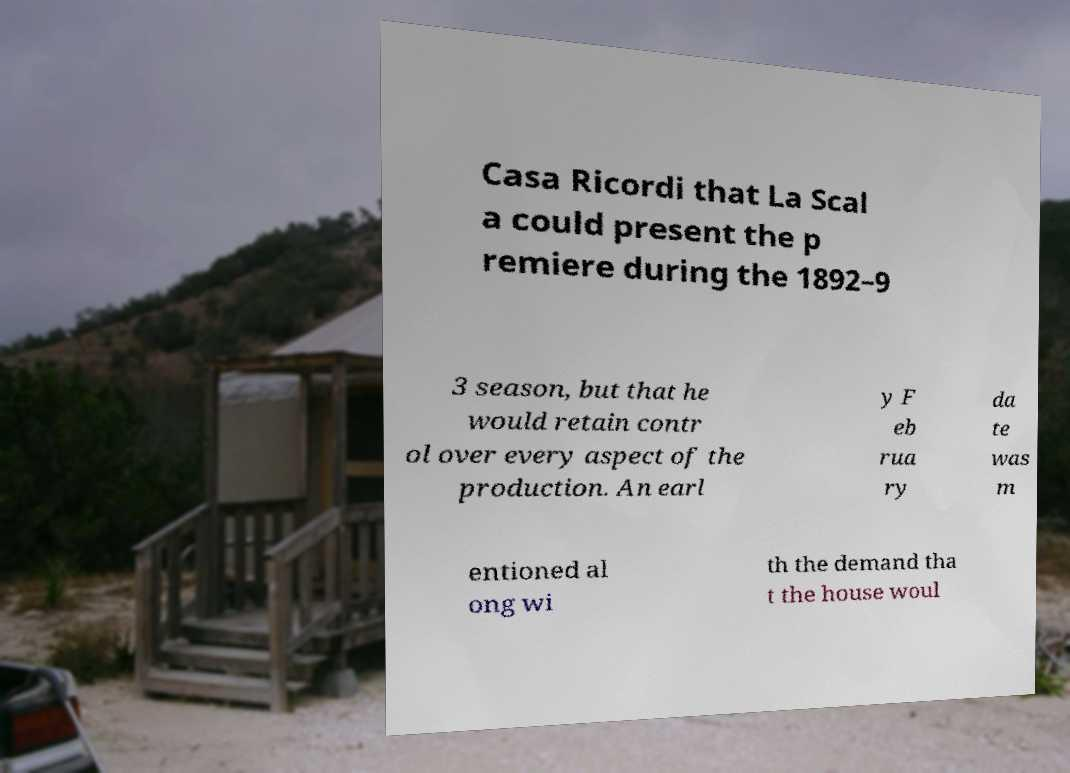Can you accurately transcribe the text from the provided image for me? Casa Ricordi that La Scal a could present the p remiere during the 1892–9 3 season, but that he would retain contr ol over every aspect of the production. An earl y F eb rua ry da te was m entioned al ong wi th the demand tha t the house woul 